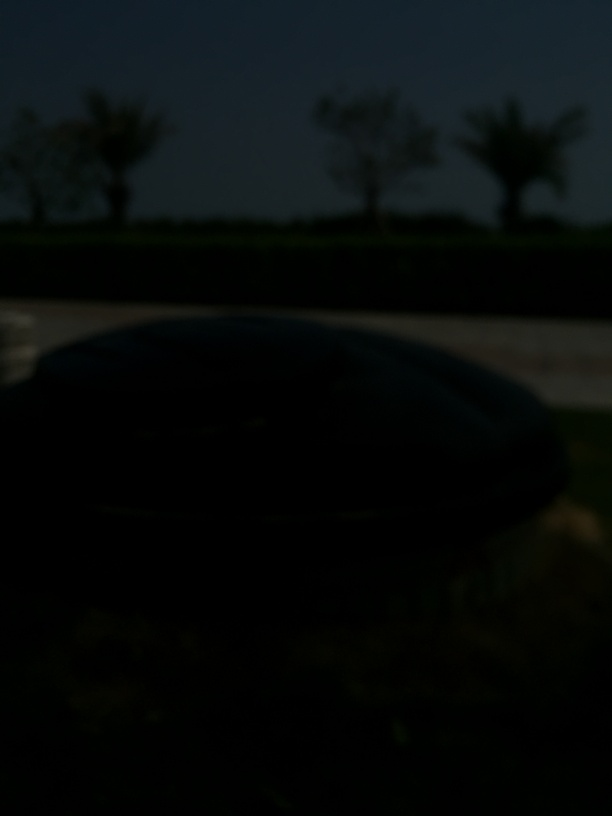What time of day does this photo appear to be taken? Given the darkness present in the image, it seems to have been taken during nighttime, or the photo might have been taken during the day with a very low exposure setting. 